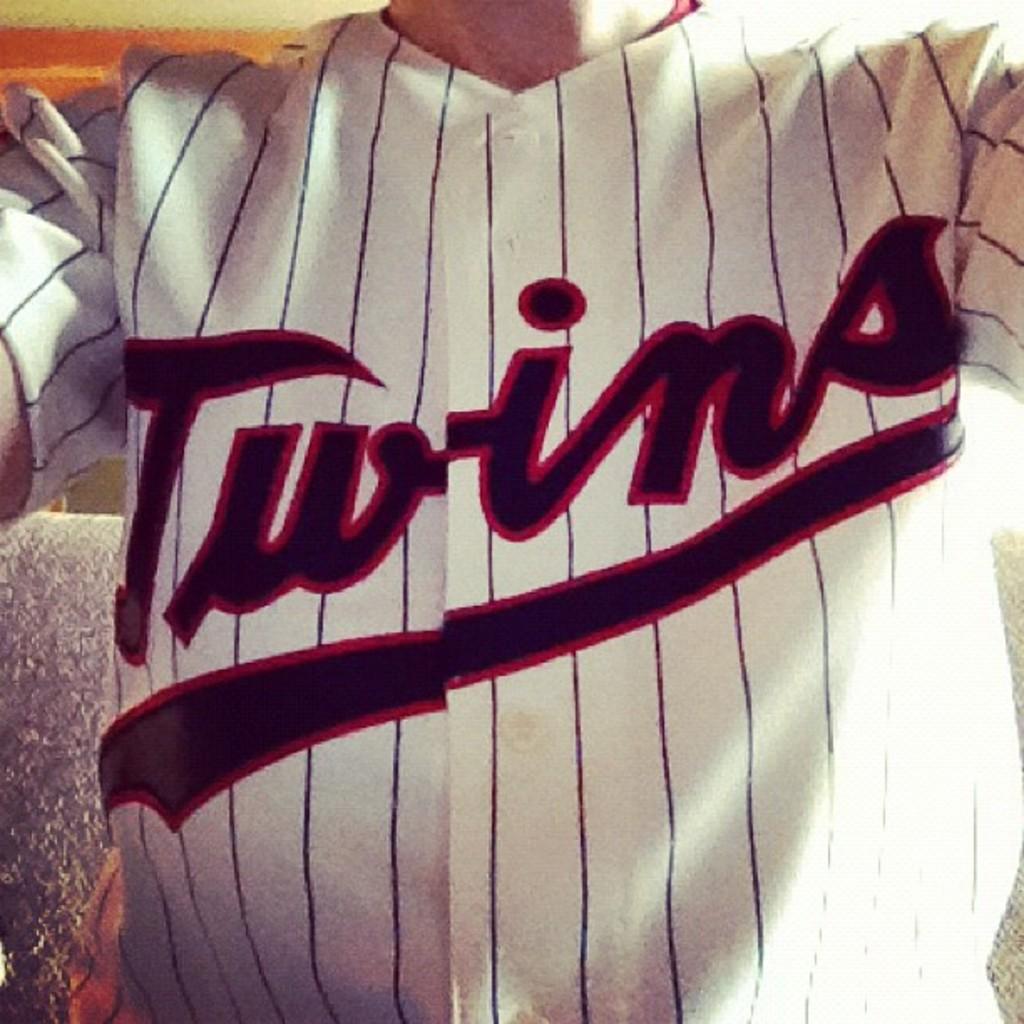What team name is on the jersey?
Your response must be concise. Twins. What name this shift?
Offer a very short reply. Twins. 